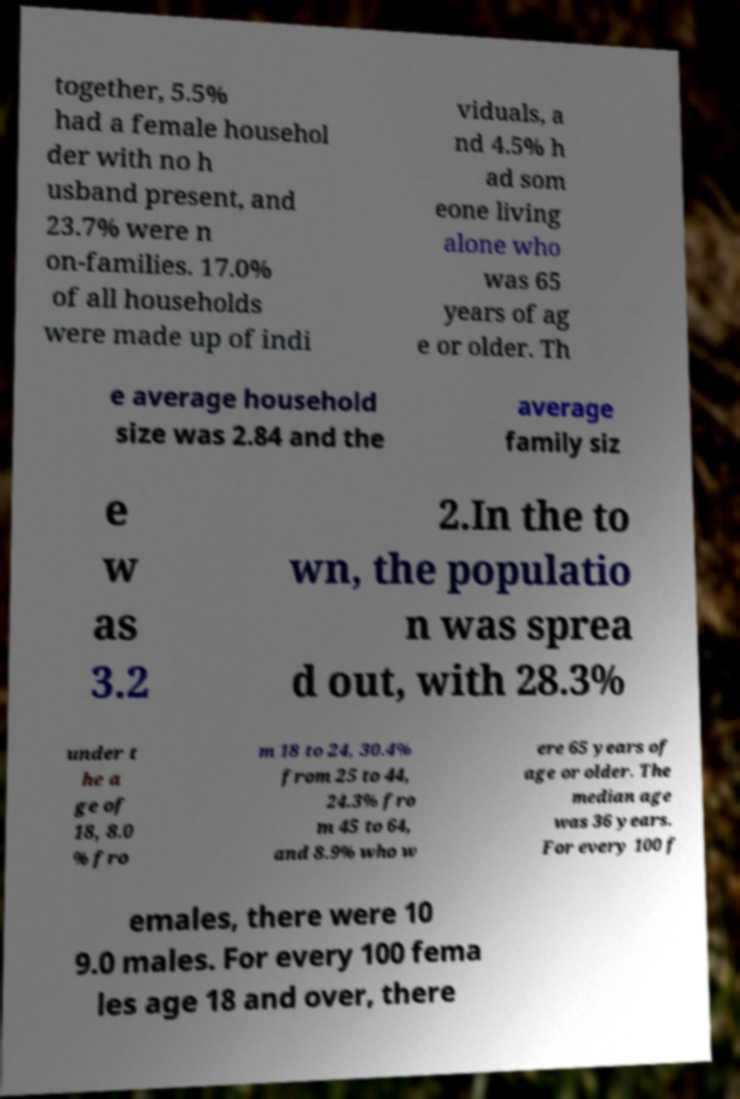What messages or text are displayed in this image? I need them in a readable, typed format. together, 5.5% had a female househol der with no h usband present, and 23.7% were n on-families. 17.0% of all households were made up of indi viduals, a nd 4.5% h ad som eone living alone who was 65 years of ag e or older. Th e average household size was 2.84 and the average family siz e w as 3.2 2.In the to wn, the populatio n was sprea d out, with 28.3% under t he a ge of 18, 8.0 % fro m 18 to 24, 30.4% from 25 to 44, 24.3% fro m 45 to 64, and 8.9% who w ere 65 years of age or older. The median age was 36 years. For every 100 f emales, there were 10 9.0 males. For every 100 fema les age 18 and over, there 